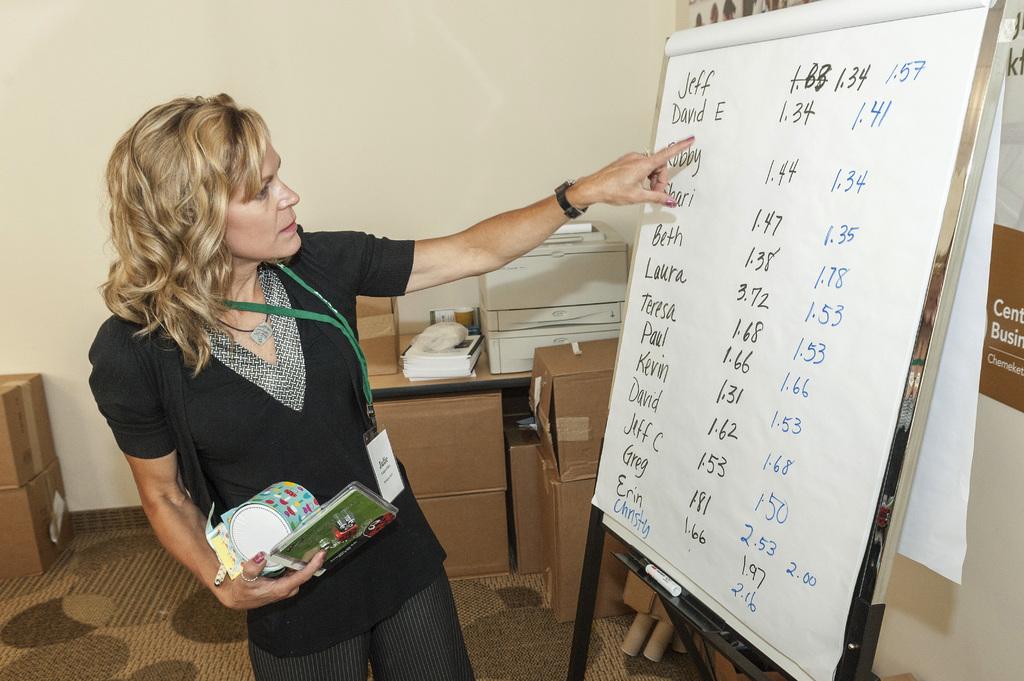What person's name is on the top of the list?
Provide a short and direct response. Jeff. What number is on top right?
Provide a short and direct response. 1.57. 